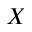<formula> <loc_0><loc_0><loc_500><loc_500>X</formula> 